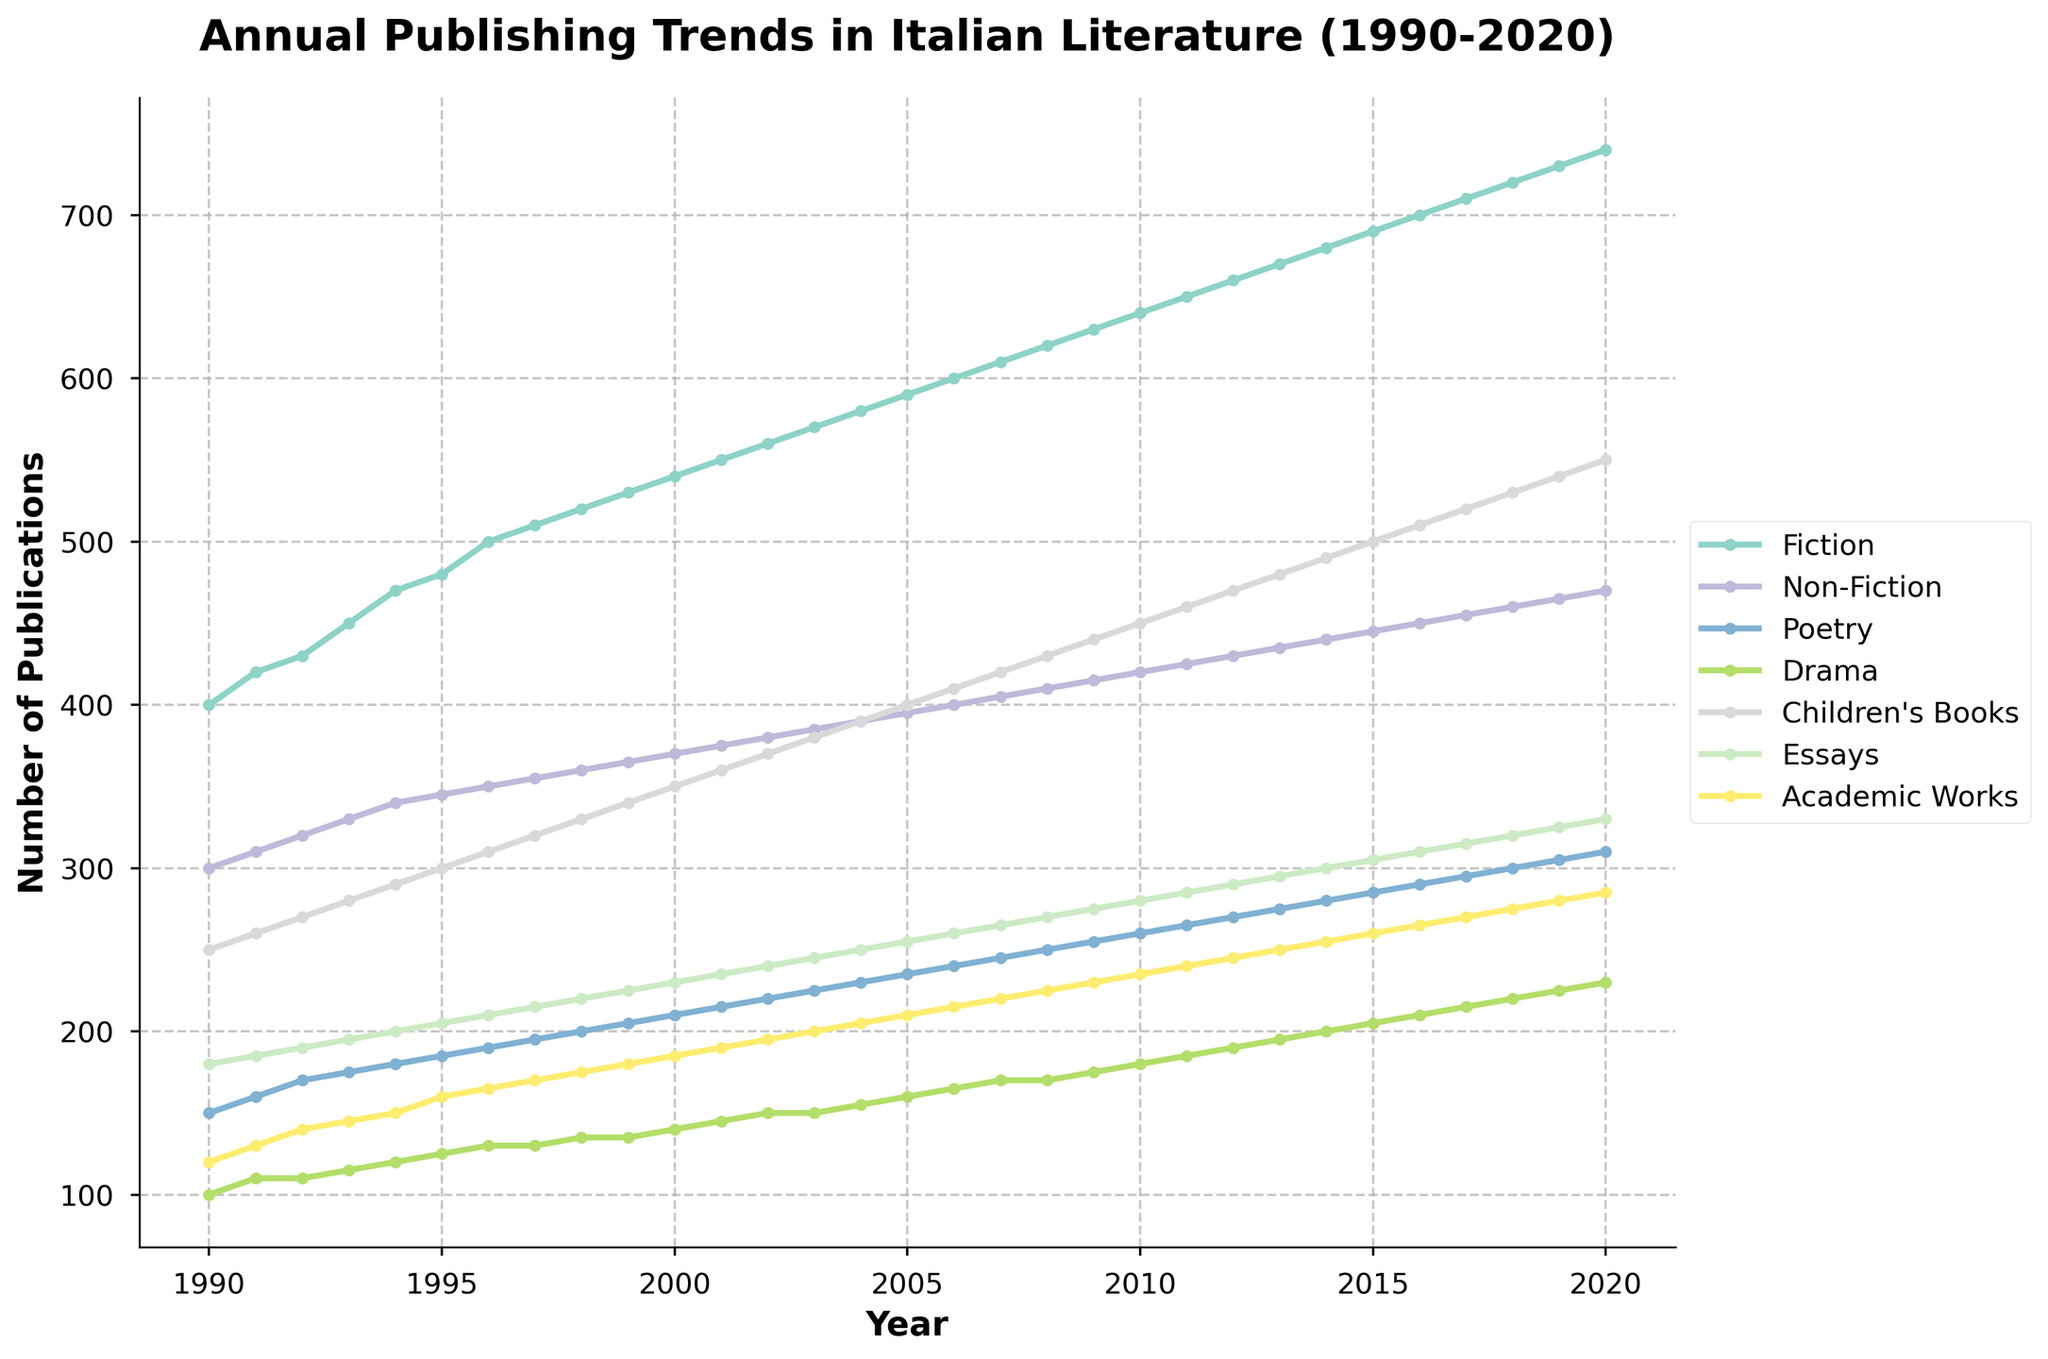What is the title of the plot? The title is positioned at the top of the plot, usually centered and in bold to highlight the focus of the figure. In this case, it specifies the content and time frame of the data represented.
Answer: Annual Publishing Trends in Italian Literature (1990-2020) What is the number of publications for Fiction in the year 2005? Locate the Fiction line on the graph (typically marked with a specific color or symbol), then find the year 2005 on the x-axis and read the value on the y-axis.
Answer: 590 Which genre had the lowest number of publications in 1993? Observe each line on the plot for the year 1993 and compare their values on the y-axis. The line with the lowest value corresponds to the genre with the fewest publications.
Answer: Drama What is the total number of publications for Children's Books from 1990 to 2000? Identify the Children's Books line on the graph and sum the y-axis values for each year from 1990 to 2000. Break it into:
250+260+270+280+290+300+310+320+330+340+350 = 3500.
Answer: 3500 Which genre experienced the most considerable increase in publications from 2000 to 2020? Compare the difference in the y-axis values for each genre between 2000 and 2020. Determine which genre's endpoint (2020) has the highest increase over its starting point (2000). Fiction: 200; Non-Fiction: 100; Poetry: 100; Drama: 90; Children's Books: 200; Essays: 100; Academic Works: 100.
Answer: Fiction & Children's Books During which years did Academic Works see at least a 10-publishing increase every year? Identify the Academic Works line, then observe the y-axis differences year by year to ensure an increase of at least 10 publications each year. Detailed examination confirms consistent 10-publication jumps from 2015-2020.
Answer: 2015-2020 Which genres showed an upward trend throughout the entire period (1990-2020)? Identify lines that consistently rise without any downtrends over the period under consideration. All genres show a consistent upward progression.
Answer: All genres In what year did Poetry surpass Drama in the number of publications for the first time? Locate the Poetry and Drama lines, and identify the first point where the Poetry line crosses above the Drama line. This occurs in the mid-1990s.
Answer: 1994 What is the growth rate of Fiction from 1995 to 2005 in terms of number of publications per year? Calculate the change in the number of Fiction publications between 1995 and 2005, and then divide by the number of years (2005-1995). Computation: (590 - 480) / 10 = 11 publications per year.
Answer: 11 publications/year How many genres had more than 400 publications in 2020? Check the y-axis values in 2020 for each genre and count how many exceed 400 publications. Genres exceeding 400: Fiction (740), Non-Fiction (470), Children’s Books (550).
Answer: Three genres 